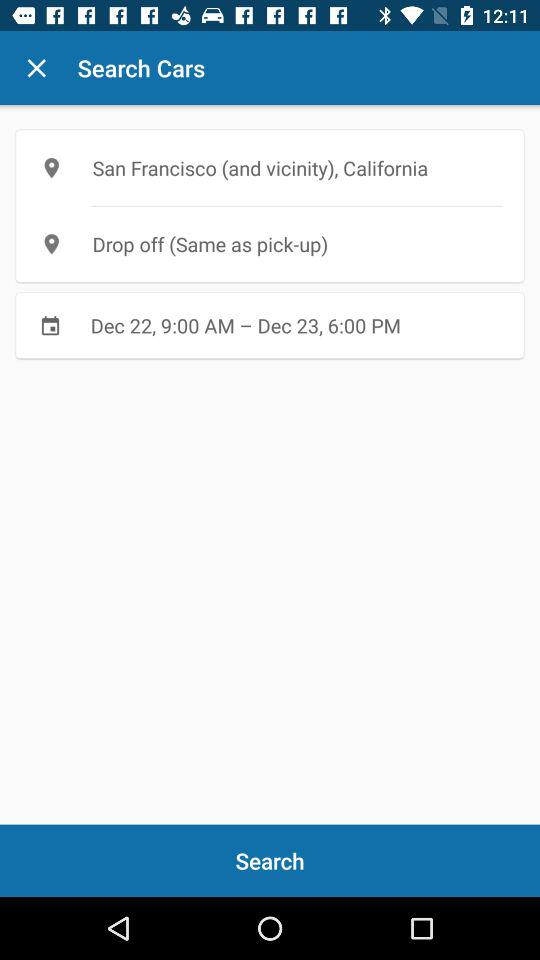What is the current location? The current location is San Francisco (and vicinity), California. 